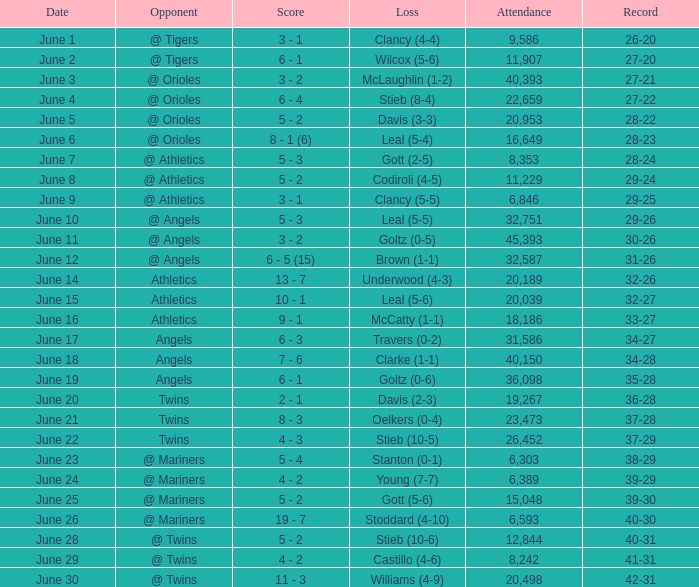What was the record for the date of June 14? 32-26. 